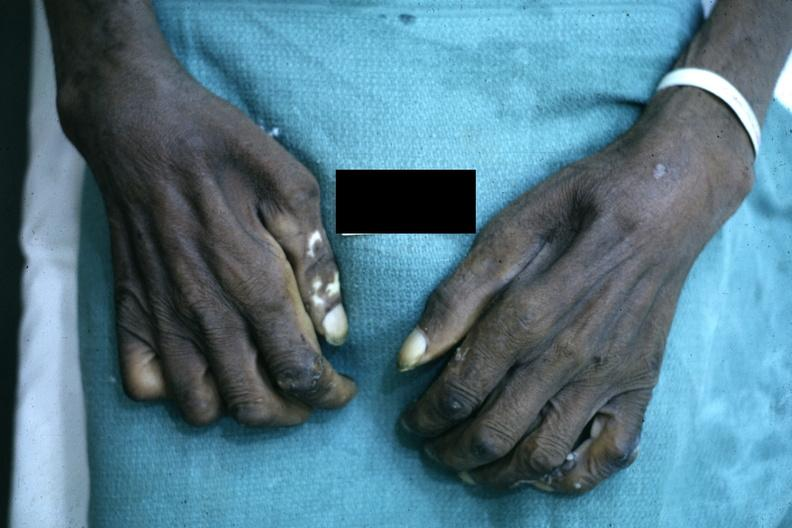why does this image show close-up excellent example of interosseous muscle atrophy said to be?
Answer the question using a single word or phrase. Due syringomyelus 